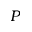Convert formula to latex. <formula><loc_0><loc_0><loc_500><loc_500>P</formula> 